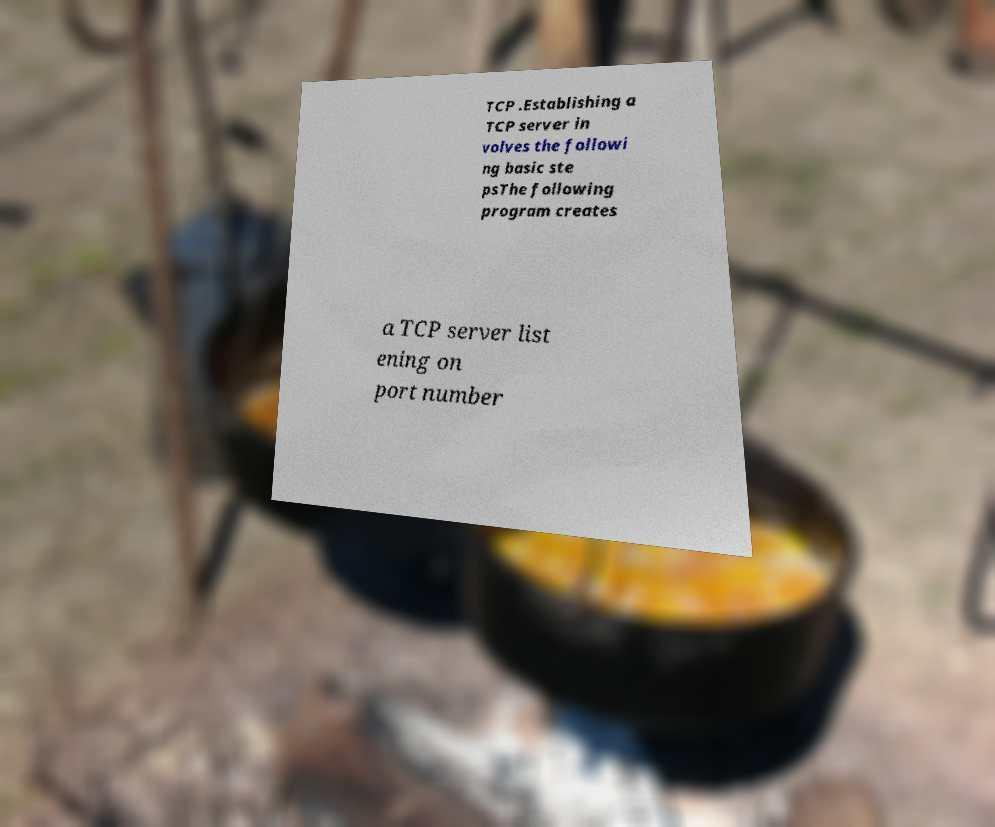Please read and relay the text visible in this image. What does it say? TCP .Establishing a TCP server in volves the followi ng basic ste psThe following program creates a TCP server list ening on port number 